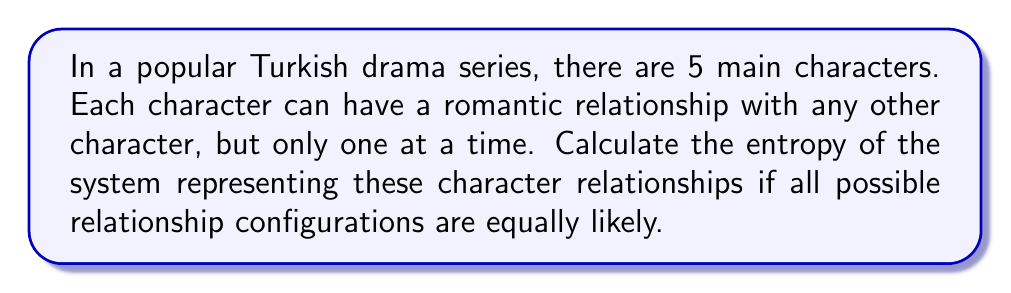Can you solve this math problem? Let's approach this step-by-step:

1) First, we need to determine the number of possible microstates (W) in this system. 
   Each character can be in a relationship with one of the other 4 characters or single.
   So, each character has 5 possible states.

2) The total number of microstates is:
   $$W = 5^5 = 3125$$

3) In statistical mechanics, the entropy S is given by Boltzmann's formula:
   $$S = k_B \ln W$$
   where $k_B$ is Boltzmann's constant.

4) For simplicity, let's assume $k_B = 1$ (this is equivalent to measuring entropy in units of $k_B$).

5) Therefore, the entropy is:
   $$S = \ln 3125$$

6) Calculating this:
   $$S = \ln 3125 \approx 8.0472$$

This value represents the entropy of the system in units of $k_B$, assuming all relationship configurations are equally probable.
Answer: $8.0472k_B$ 